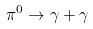Convert formula to latex. <formula><loc_0><loc_0><loc_500><loc_500>\pi ^ { 0 } \rightarrow \gamma + \gamma</formula> 